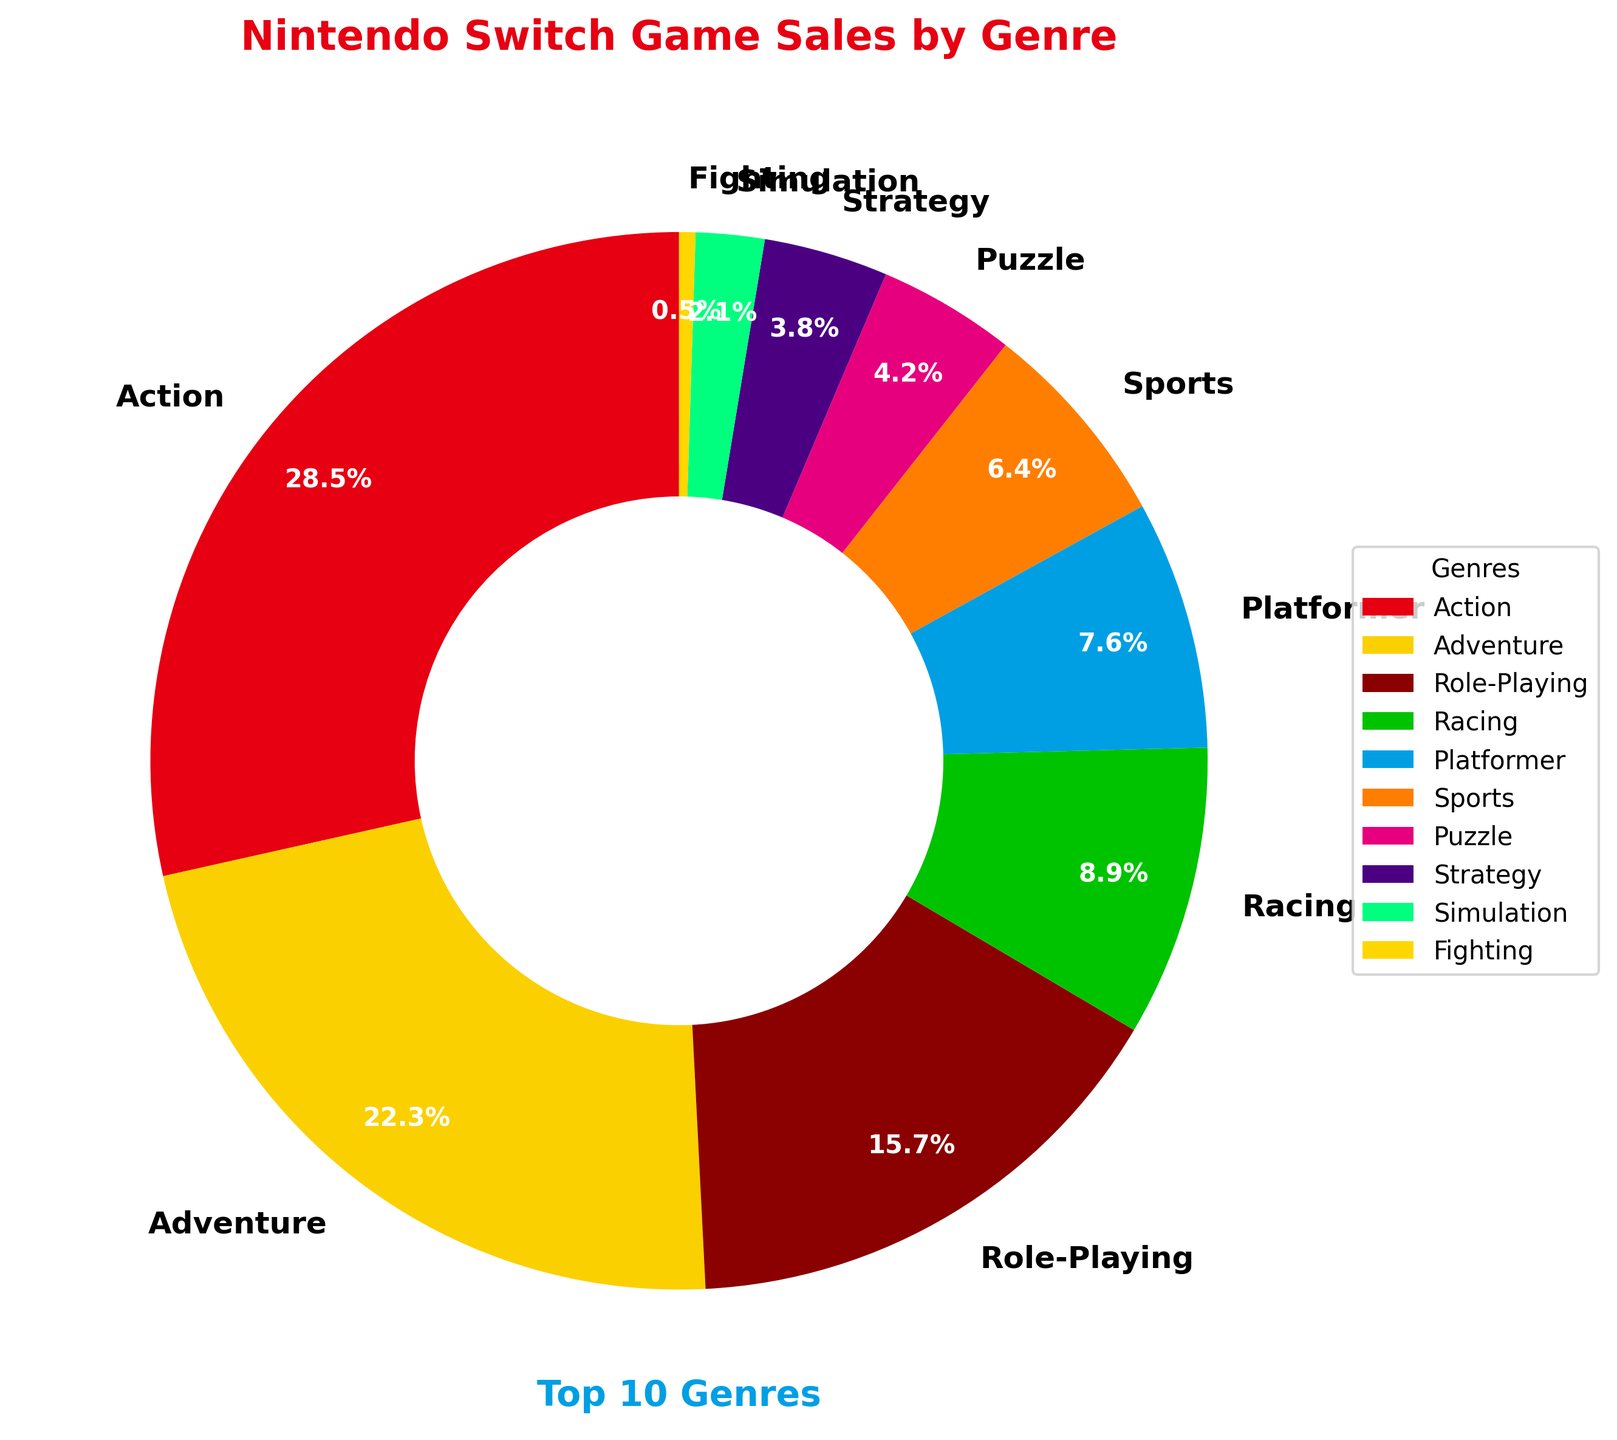Which genre has the highest sales percentage? The genre with the highest sales percentage is represented by the biggest slice of the pie chart. By looking at the chart, the largest slice belongs to the Action genre.
Answer: Action What is the combined sales percentage of Racing and Sports genres? First, locate the percentages for Racing and Sports genres. Racing is 8.9% and Sports is 6.4%. Adding these together gives 8.9% + 6.4% = 15.3%.
Answer: 15.3% Which genre has a smaller sales percentage: Puzzle or Platformer? Compare the slices for Puzzle and Platformer in the pie chart. Puzzle has 4.2%, and Platformer has 7.6%. Since 4.2% is less than 7.6%, the Puzzle genre has a smaller sales percentage.
Answer: Puzzle How much greater is the sales percentage of Role-Playing games compared to Simulation games? Role-Playing games have a sales percentage of 15.7%, and Simulation games have 2.1%. Subtracting these gives 15.7% - 2.1% = 13.6%.
Answer: 13.6% Which genre has the smallest sales percentage, and what is it? The smallest slice in the pie chart represents the genre with the smallest sales percentage. The smallest slice belongs to the Fighting genre with a sales percentage of 0.5%.
Answer: Fighting What is the average sales percentage of Adventure, Strategy, and Simulation genres? Add the percentages of Adventure (22.3%), Strategy (3.8%), and Simulation (2.1%). The total is 22.3% + 3.8% + 2.1% = 28.2%. The average is 28.2% / 3 = 9.4%.
Answer: 9.4% Which genre has a greater sales percentage: Role-Playing or Adventure? Look at the corresponding slices in the pie chart. Role-Playing has 15.7%, while Adventure has 22.3%. Since 22.3% is greater than 15.7%, Adventure has a greater sales percentage.
Answer: Adventure What percentage of the sales does the top three genres (Action, Adventure, Role-Playing) sum up to? The top three genres are Action (28.5%), Adventure (22.3%), and Role-Playing (15.7%). Adding these gives 28.5% + 22.3% + 15.7% = 66.5%.
Answer: 66.5% 